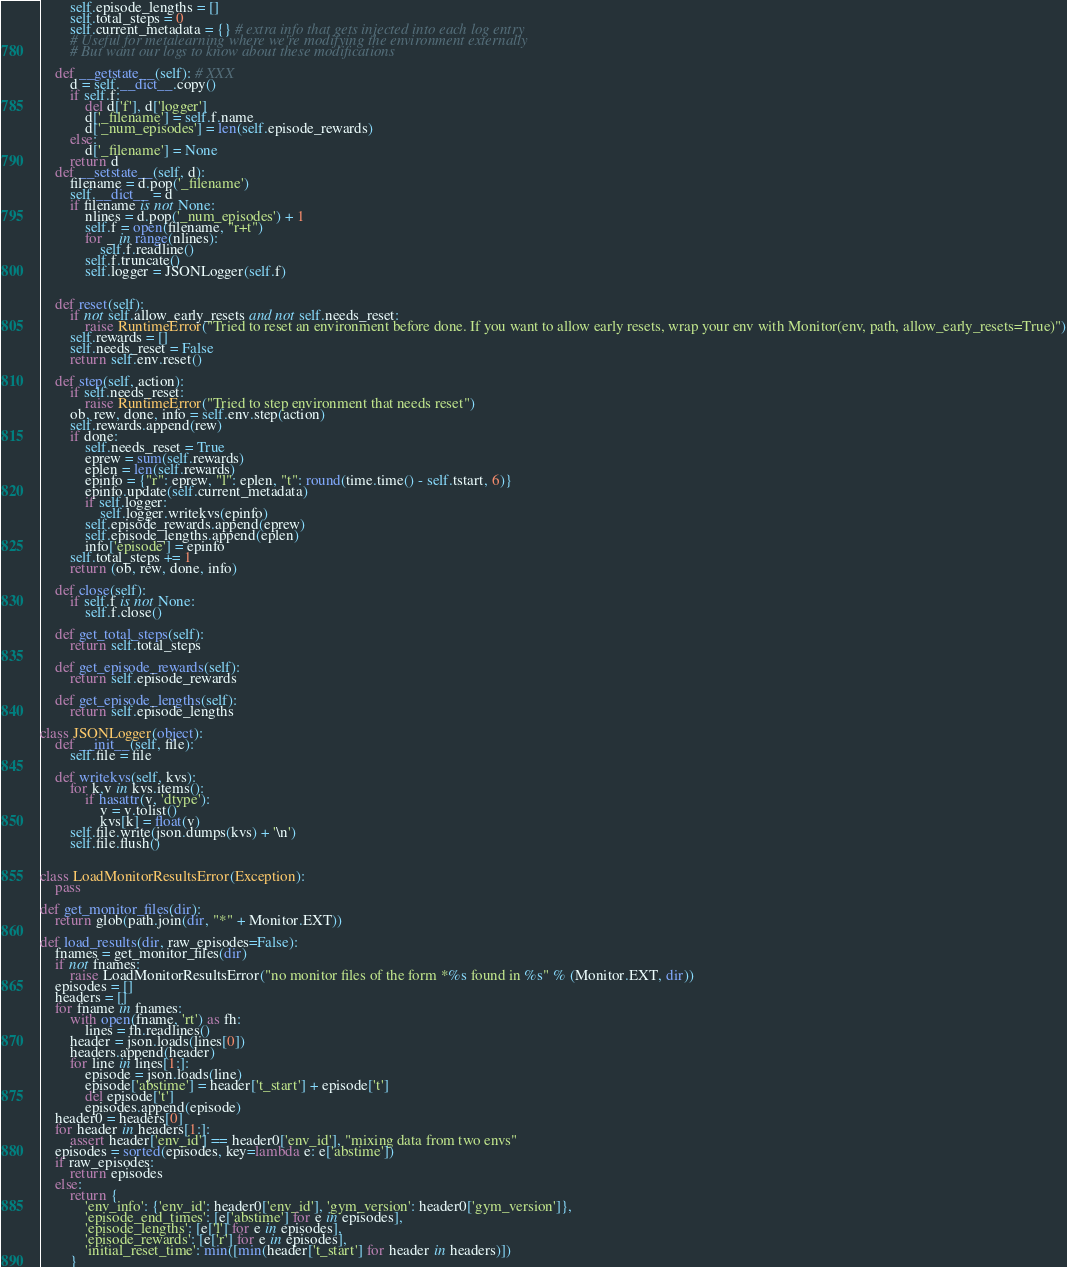Convert code to text. <code><loc_0><loc_0><loc_500><loc_500><_Python_>        self.episode_lengths = []
        self.total_steps = 0
        self.current_metadata = {} # extra info that gets injected into each log entry
        # Useful for metalearning where we're modifying the environment externally
        # But want our logs to know about these modifications

    def __getstate__(self): # XXX
        d = self.__dict__.copy()
        if self.f:
            del d['f'], d['logger']
            d['_filename'] = self.f.name
            d['_num_episodes'] = len(self.episode_rewards)
        else:
            d['_filename'] = None
        return d
    def __setstate__(self, d):
        filename = d.pop('_filename')
        self.__dict__ = d
        if filename is not None:
            nlines = d.pop('_num_episodes') + 1
            self.f = open(filename, "r+t")
            for _ in range(nlines):
                self.f.readline()
            self.f.truncate()        
            self.logger = JSONLogger(self.f)


    def reset(self):
        if not self.allow_early_resets and not self.needs_reset:
            raise RuntimeError("Tried to reset an environment before done. If you want to allow early resets, wrap your env with Monitor(env, path, allow_early_resets=True)")
        self.rewards = []
        self.needs_reset = False
        return self.env.reset()

    def step(self, action):
        if self.needs_reset:
            raise RuntimeError("Tried to step environment that needs reset")
        ob, rew, done, info = self.env.step(action)
        self.rewards.append(rew)
        if done:
            self.needs_reset = True
            eprew = sum(self.rewards)
            eplen = len(self.rewards)
            epinfo = {"r": eprew, "l": eplen, "t": round(time.time() - self.tstart, 6)}
            epinfo.update(self.current_metadata)
            if self.logger:
                self.logger.writekvs(epinfo)
            self.episode_rewards.append(eprew)
            self.episode_lengths.append(eplen)
            info['episode'] = epinfo
        self.total_steps += 1
        return (ob, rew, done, info)

    def close(self):
        if self.f is not None:
            self.f.close()

    def get_total_steps(self):
        return self.total_steps

    def get_episode_rewards(self):
        return self.episode_rewards

    def get_episode_lengths(self):
        return self.episode_lengths

class JSONLogger(object):
    def __init__(self, file):
        self.file = file

    def writekvs(self, kvs):
        for k,v in kvs.items():
            if hasattr(v, 'dtype'):
                v = v.tolist()
                kvs[k] = float(v)
        self.file.write(json.dumps(kvs) + '\n')
        self.file.flush()


class LoadMonitorResultsError(Exception):
    pass

def get_monitor_files(dir):
    return glob(path.join(dir, "*" + Monitor.EXT))

def load_results(dir, raw_episodes=False):
    fnames = get_monitor_files(dir)
    if not fnames:
        raise LoadMonitorResultsError("no monitor files of the form *%s found in %s" % (Monitor.EXT, dir))
    episodes = []
    headers = []
    for fname in fnames:
        with open(fname, 'rt') as fh:
            lines = fh.readlines()
        header = json.loads(lines[0])
        headers.append(header)
        for line in lines[1:]:
            episode = json.loads(line)
            episode['abstime'] = header['t_start'] + episode['t']
            del episode['t']
            episodes.append(episode)
    header0 = headers[0]
    for header in headers[1:]:
        assert header['env_id'] == header0['env_id'], "mixing data from two envs"
    episodes = sorted(episodes, key=lambda e: e['abstime'])
    if raw_episodes: 
        return episodes
    else:
        return {
            'env_info': {'env_id': header0['env_id'], 'gym_version': header0['gym_version']},
            'episode_end_times': [e['abstime'] for e in episodes],
            'episode_lengths': [e['l'] for e in episodes],
            'episode_rewards': [e['r'] for e in episodes],
            'initial_reset_time': min([min(header['t_start'] for header in headers)])
        }
</code> 